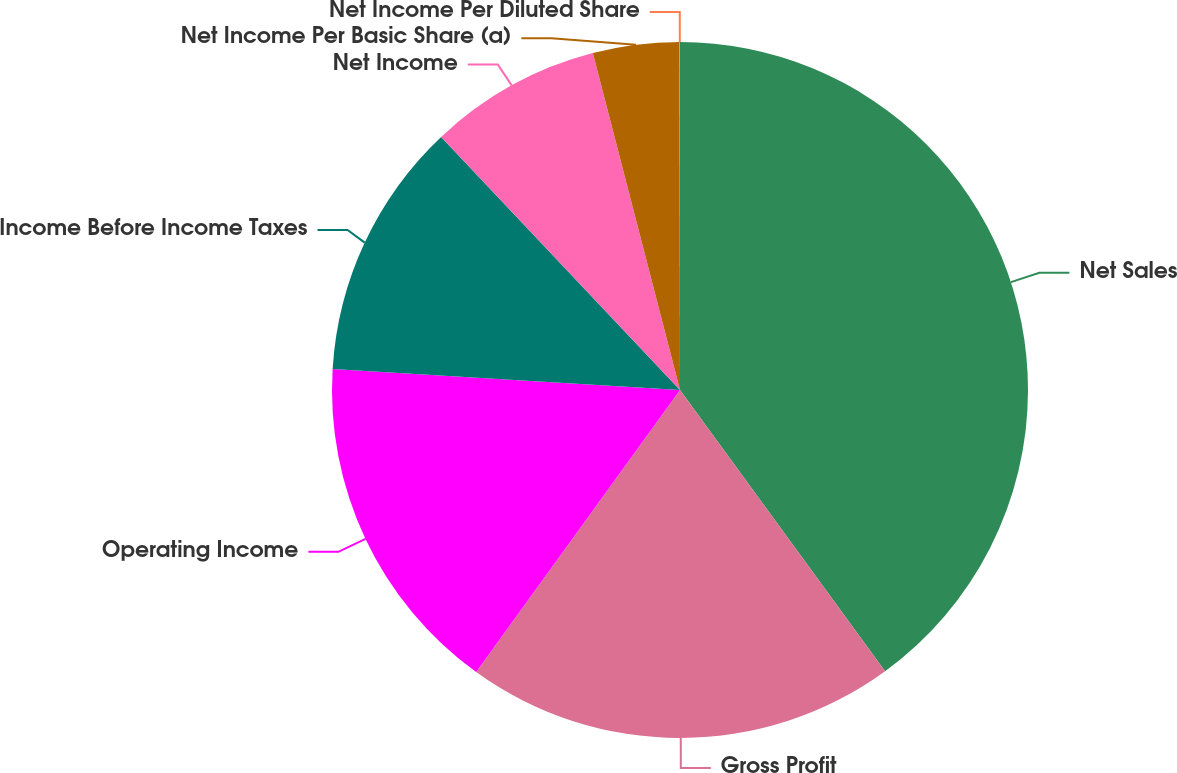<chart> <loc_0><loc_0><loc_500><loc_500><pie_chart><fcel>Net Sales<fcel>Gross Profit<fcel>Operating Income<fcel>Income Before Income Taxes<fcel>Net Income<fcel>Net Income Per Basic Share (a)<fcel>Net Income Per Diluted Share<nl><fcel>39.97%<fcel>19.99%<fcel>16.0%<fcel>12.0%<fcel>8.01%<fcel>4.01%<fcel>0.02%<nl></chart> 